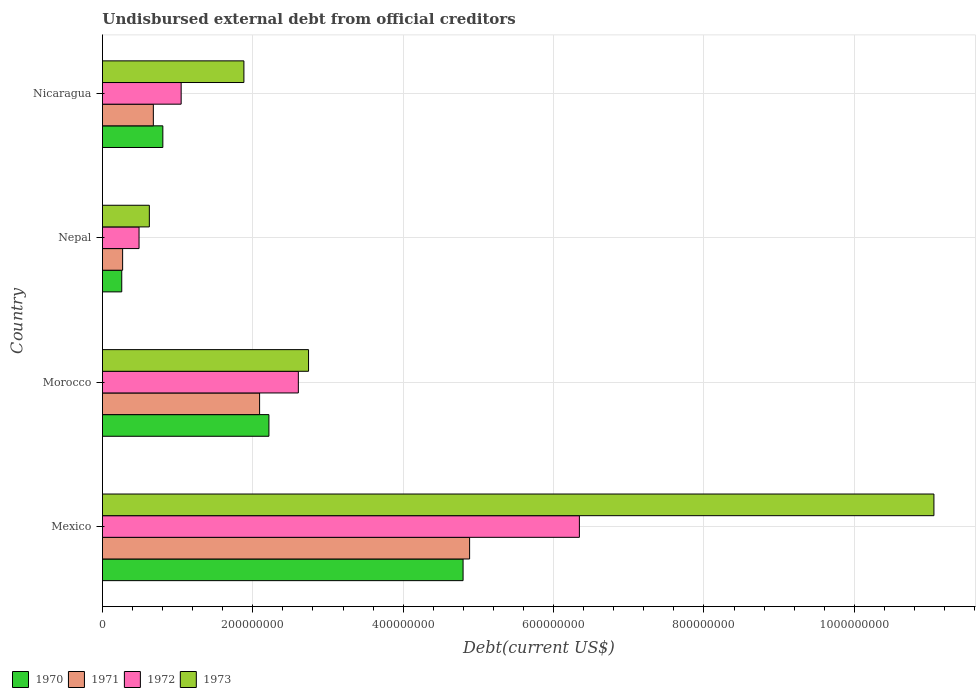How many different coloured bars are there?
Your answer should be very brief. 4. How many groups of bars are there?
Make the answer very short. 4. Are the number of bars per tick equal to the number of legend labels?
Ensure brevity in your answer.  Yes. Are the number of bars on each tick of the Y-axis equal?
Your response must be concise. Yes. How many bars are there on the 2nd tick from the top?
Provide a short and direct response. 4. What is the label of the 1st group of bars from the top?
Your answer should be compact. Nicaragua. In how many cases, is the number of bars for a given country not equal to the number of legend labels?
Keep it short and to the point. 0. What is the total debt in 1970 in Nicaragua?
Provide a succinct answer. 8.03e+07. Across all countries, what is the maximum total debt in 1973?
Your answer should be compact. 1.11e+09. Across all countries, what is the minimum total debt in 1972?
Offer a terse response. 4.87e+07. In which country was the total debt in 1972 minimum?
Provide a succinct answer. Nepal. What is the total total debt in 1973 in the graph?
Your answer should be very brief. 1.63e+09. What is the difference between the total debt in 1973 in Mexico and that in Nepal?
Your answer should be compact. 1.04e+09. What is the difference between the total debt in 1972 in Morocco and the total debt in 1971 in Mexico?
Your response must be concise. -2.28e+08. What is the average total debt in 1973 per country?
Your answer should be compact. 4.08e+08. What is the difference between the total debt in 1972 and total debt in 1971 in Nepal?
Offer a terse response. 2.18e+07. What is the ratio of the total debt in 1971 in Morocco to that in Nicaragua?
Give a very brief answer. 3.09. Is the difference between the total debt in 1972 in Mexico and Nepal greater than the difference between the total debt in 1971 in Mexico and Nepal?
Ensure brevity in your answer.  Yes. What is the difference between the highest and the second highest total debt in 1972?
Give a very brief answer. 3.74e+08. What is the difference between the highest and the lowest total debt in 1971?
Offer a terse response. 4.62e+08. In how many countries, is the total debt in 1973 greater than the average total debt in 1973 taken over all countries?
Provide a succinct answer. 1. Is the sum of the total debt in 1971 in Mexico and Nepal greater than the maximum total debt in 1973 across all countries?
Your answer should be very brief. No. Is it the case that in every country, the sum of the total debt in 1972 and total debt in 1973 is greater than the sum of total debt in 1970 and total debt in 1971?
Offer a very short reply. No. What does the 1st bar from the top in Nicaragua represents?
Offer a very short reply. 1973. What does the 4th bar from the bottom in Mexico represents?
Make the answer very short. 1973. How many countries are there in the graph?
Offer a very short reply. 4. What is the difference between two consecutive major ticks on the X-axis?
Provide a short and direct response. 2.00e+08. Does the graph contain any zero values?
Ensure brevity in your answer.  No. What is the title of the graph?
Your response must be concise. Undisbursed external debt from official creditors. Does "1998" appear as one of the legend labels in the graph?
Provide a short and direct response. No. What is the label or title of the X-axis?
Ensure brevity in your answer.  Debt(current US$). What is the Debt(current US$) in 1970 in Mexico?
Give a very brief answer. 4.80e+08. What is the Debt(current US$) in 1971 in Mexico?
Make the answer very short. 4.88e+08. What is the Debt(current US$) in 1972 in Mexico?
Keep it short and to the point. 6.34e+08. What is the Debt(current US$) in 1973 in Mexico?
Give a very brief answer. 1.11e+09. What is the Debt(current US$) in 1970 in Morocco?
Provide a short and direct response. 2.21e+08. What is the Debt(current US$) in 1971 in Morocco?
Offer a terse response. 2.09e+08. What is the Debt(current US$) in 1972 in Morocco?
Provide a short and direct response. 2.61e+08. What is the Debt(current US$) of 1973 in Morocco?
Keep it short and to the point. 2.74e+08. What is the Debt(current US$) of 1970 in Nepal?
Provide a succinct answer. 2.57e+07. What is the Debt(current US$) of 1971 in Nepal?
Your answer should be very brief. 2.68e+07. What is the Debt(current US$) of 1972 in Nepal?
Make the answer very short. 4.87e+07. What is the Debt(current US$) of 1973 in Nepal?
Make the answer very short. 6.23e+07. What is the Debt(current US$) in 1970 in Nicaragua?
Your answer should be compact. 8.03e+07. What is the Debt(current US$) in 1971 in Nicaragua?
Provide a succinct answer. 6.77e+07. What is the Debt(current US$) in 1972 in Nicaragua?
Offer a very short reply. 1.05e+08. What is the Debt(current US$) in 1973 in Nicaragua?
Give a very brief answer. 1.88e+08. Across all countries, what is the maximum Debt(current US$) in 1970?
Make the answer very short. 4.80e+08. Across all countries, what is the maximum Debt(current US$) in 1971?
Offer a terse response. 4.88e+08. Across all countries, what is the maximum Debt(current US$) in 1972?
Make the answer very short. 6.34e+08. Across all countries, what is the maximum Debt(current US$) of 1973?
Offer a very short reply. 1.11e+09. Across all countries, what is the minimum Debt(current US$) of 1970?
Keep it short and to the point. 2.57e+07. Across all countries, what is the minimum Debt(current US$) in 1971?
Give a very brief answer. 2.68e+07. Across all countries, what is the minimum Debt(current US$) in 1972?
Provide a succinct answer. 4.87e+07. Across all countries, what is the minimum Debt(current US$) of 1973?
Keep it short and to the point. 6.23e+07. What is the total Debt(current US$) of 1970 in the graph?
Your answer should be very brief. 8.07e+08. What is the total Debt(current US$) of 1971 in the graph?
Ensure brevity in your answer.  7.92e+08. What is the total Debt(current US$) of 1972 in the graph?
Your answer should be very brief. 1.05e+09. What is the total Debt(current US$) in 1973 in the graph?
Give a very brief answer. 1.63e+09. What is the difference between the Debt(current US$) in 1970 in Mexico and that in Morocco?
Give a very brief answer. 2.58e+08. What is the difference between the Debt(current US$) of 1971 in Mexico and that in Morocco?
Keep it short and to the point. 2.79e+08. What is the difference between the Debt(current US$) of 1972 in Mexico and that in Morocco?
Provide a short and direct response. 3.74e+08. What is the difference between the Debt(current US$) in 1973 in Mexico and that in Morocco?
Ensure brevity in your answer.  8.32e+08. What is the difference between the Debt(current US$) of 1970 in Mexico and that in Nepal?
Offer a terse response. 4.54e+08. What is the difference between the Debt(current US$) of 1971 in Mexico and that in Nepal?
Your answer should be compact. 4.62e+08. What is the difference between the Debt(current US$) of 1972 in Mexico and that in Nepal?
Provide a short and direct response. 5.86e+08. What is the difference between the Debt(current US$) in 1973 in Mexico and that in Nepal?
Make the answer very short. 1.04e+09. What is the difference between the Debt(current US$) of 1970 in Mexico and that in Nicaragua?
Offer a terse response. 3.99e+08. What is the difference between the Debt(current US$) of 1971 in Mexico and that in Nicaragua?
Your answer should be very brief. 4.21e+08. What is the difference between the Debt(current US$) of 1972 in Mexico and that in Nicaragua?
Make the answer very short. 5.30e+08. What is the difference between the Debt(current US$) of 1973 in Mexico and that in Nicaragua?
Your answer should be compact. 9.18e+08. What is the difference between the Debt(current US$) of 1970 in Morocco and that in Nepal?
Your answer should be compact. 1.96e+08. What is the difference between the Debt(current US$) in 1971 in Morocco and that in Nepal?
Ensure brevity in your answer.  1.82e+08. What is the difference between the Debt(current US$) of 1972 in Morocco and that in Nepal?
Keep it short and to the point. 2.12e+08. What is the difference between the Debt(current US$) of 1973 in Morocco and that in Nepal?
Your answer should be compact. 2.12e+08. What is the difference between the Debt(current US$) of 1970 in Morocco and that in Nicaragua?
Offer a very short reply. 1.41e+08. What is the difference between the Debt(current US$) in 1971 in Morocco and that in Nicaragua?
Offer a terse response. 1.41e+08. What is the difference between the Debt(current US$) of 1972 in Morocco and that in Nicaragua?
Keep it short and to the point. 1.56e+08. What is the difference between the Debt(current US$) in 1973 in Morocco and that in Nicaragua?
Your answer should be compact. 8.60e+07. What is the difference between the Debt(current US$) in 1970 in Nepal and that in Nicaragua?
Your answer should be compact. -5.47e+07. What is the difference between the Debt(current US$) in 1971 in Nepal and that in Nicaragua?
Your response must be concise. -4.08e+07. What is the difference between the Debt(current US$) of 1972 in Nepal and that in Nicaragua?
Your response must be concise. -5.60e+07. What is the difference between the Debt(current US$) of 1973 in Nepal and that in Nicaragua?
Your response must be concise. -1.26e+08. What is the difference between the Debt(current US$) in 1970 in Mexico and the Debt(current US$) in 1971 in Morocco?
Offer a terse response. 2.71e+08. What is the difference between the Debt(current US$) of 1970 in Mexico and the Debt(current US$) of 1972 in Morocco?
Your answer should be compact. 2.19e+08. What is the difference between the Debt(current US$) of 1970 in Mexico and the Debt(current US$) of 1973 in Morocco?
Your answer should be compact. 2.06e+08. What is the difference between the Debt(current US$) of 1971 in Mexico and the Debt(current US$) of 1972 in Morocco?
Ensure brevity in your answer.  2.28e+08. What is the difference between the Debt(current US$) of 1971 in Mexico and the Debt(current US$) of 1973 in Morocco?
Your response must be concise. 2.14e+08. What is the difference between the Debt(current US$) of 1972 in Mexico and the Debt(current US$) of 1973 in Morocco?
Ensure brevity in your answer.  3.60e+08. What is the difference between the Debt(current US$) in 1970 in Mexico and the Debt(current US$) in 1971 in Nepal?
Offer a very short reply. 4.53e+08. What is the difference between the Debt(current US$) in 1970 in Mexico and the Debt(current US$) in 1972 in Nepal?
Your response must be concise. 4.31e+08. What is the difference between the Debt(current US$) of 1970 in Mexico and the Debt(current US$) of 1973 in Nepal?
Ensure brevity in your answer.  4.17e+08. What is the difference between the Debt(current US$) of 1971 in Mexico and the Debt(current US$) of 1972 in Nepal?
Your answer should be very brief. 4.40e+08. What is the difference between the Debt(current US$) in 1971 in Mexico and the Debt(current US$) in 1973 in Nepal?
Provide a short and direct response. 4.26e+08. What is the difference between the Debt(current US$) of 1972 in Mexico and the Debt(current US$) of 1973 in Nepal?
Provide a succinct answer. 5.72e+08. What is the difference between the Debt(current US$) in 1970 in Mexico and the Debt(current US$) in 1971 in Nicaragua?
Your response must be concise. 4.12e+08. What is the difference between the Debt(current US$) in 1970 in Mexico and the Debt(current US$) in 1972 in Nicaragua?
Your response must be concise. 3.75e+08. What is the difference between the Debt(current US$) in 1970 in Mexico and the Debt(current US$) in 1973 in Nicaragua?
Offer a terse response. 2.92e+08. What is the difference between the Debt(current US$) in 1971 in Mexico and the Debt(current US$) in 1972 in Nicaragua?
Provide a short and direct response. 3.84e+08. What is the difference between the Debt(current US$) in 1971 in Mexico and the Debt(current US$) in 1973 in Nicaragua?
Keep it short and to the point. 3.00e+08. What is the difference between the Debt(current US$) in 1972 in Mexico and the Debt(current US$) in 1973 in Nicaragua?
Make the answer very short. 4.46e+08. What is the difference between the Debt(current US$) in 1970 in Morocco and the Debt(current US$) in 1971 in Nepal?
Your answer should be compact. 1.95e+08. What is the difference between the Debt(current US$) in 1970 in Morocco and the Debt(current US$) in 1972 in Nepal?
Offer a terse response. 1.73e+08. What is the difference between the Debt(current US$) in 1970 in Morocco and the Debt(current US$) in 1973 in Nepal?
Provide a succinct answer. 1.59e+08. What is the difference between the Debt(current US$) of 1971 in Morocco and the Debt(current US$) of 1972 in Nepal?
Offer a very short reply. 1.60e+08. What is the difference between the Debt(current US$) of 1971 in Morocco and the Debt(current US$) of 1973 in Nepal?
Offer a terse response. 1.47e+08. What is the difference between the Debt(current US$) of 1972 in Morocco and the Debt(current US$) of 1973 in Nepal?
Provide a succinct answer. 1.98e+08. What is the difference between the Debt(current US$) in 1970 in Morocco and the Debt(current US$) in 1971 in Nicaragua?
Ensure brevity in your answer.  1.54e+08. What is the difference between the Debt(current US$) in 1970 in Morocco and the Debt(current US$) in 1972 in Nicaragua?
Provide a succinct answer. 1.17e+08. What is the difference between the Debt(current US$) in 1970 in Morocco and the Debt(current US$) in 1973 in Nicaragua?
Provide a succinct answer. 3.33e+07. What is the difference between the Debt(current US$) of 1971 in Morocco and the Debt(current US$) of 1972 in Nicaragua?
Provide a short and direct response. 1.04e+08. What is the difference between the Debt(current US$) in 1971 in Morocco and the Debt(current US$) in 1973 in Nicaragua?
Offer a very short reply. 2.09e+07. What is the difference between the Debt(current US$) in 1972 in Morocco and the Debt(current US$) in 1973 in Nicaragua?
Your answer should be very brief. 7.24e+07. What is the difference between the Debt(current US$) of 1970 in Nepal and the Debt(current US$) of 1971 in Nicaragua?
Make the answer very short. -4.20e+07. What is the difference between the Debt(current US$) of 1970 in Nepal and the Debt(current US$) of 1972 in Nicaragua?
Your answer should be compact. -7.90e+07. What is the difference between the Debt(current US$) in 1970 in Nepal and the Debt(current US$) in 1973 in Nicaragua?
Keep it short and to the point. -1.62e+08. What is the difference between the Debt(current US$) in 1971 in Nepal and the Debt(current US$) in 1972 in Nicaragua?
Your response must be concise. -7.78e+07. What is the difference between the Debt(current US$) in 1971 in Nepal and the Debt(current US$) in 1973 in Nicaragua?
Make the answer very short. -1.61e+08. What is the difference between the Debt(current US$) in 1972 in Nepal and the Debt(current US$) in 1973 in Nicaragua?
Keep it short and to the point. -1.39e+08. What is the average Debt(current US$) in 1970 per country?
Ensure brevity in your answer.  2.02e+08. What is the average Debt(current US$) in 1971 per country?
Offer a terse response. 1.98e+08. What is the average Debt(current US$) in 1972 per country?
Your answer should be compact. 2.62e+08. What is the average Debt(current US$) of 1973 per country?
Your answer should be very brief. 4.08e+08. What is the difference between the Debt(current US$) of 1970 and Debt(current US$) of 1971 in Mexico?
Offer a very short reply. -8.70e+06. What is the difference between the Debt(current US$) in 1970 and Debt(current US$) in 1972 in Mexico?
Offer a terse response. -1.55e+08. What is the difference between the Debt(current US$) of 1970 and Debt(current US$) of 1973 in Mexico?
Give a very brief answer. -6.26e+08. What is the difference between the Debt(current US$) in 1971 and Debt(current US$) in 1972 in Mexico?
Keep it short and to the point. -1.46e+08. What is the difference between the Debt(current US$) in 1971 and Debt(current US$) in 1973 in Mexico?
Your response must be concise. -6.18e+08. What is the difference between the Debt(current US$) of 1972 and Debt(current US$) of 1973 in Mexico?
Give a very brief answer. -4.72e+08. What is the difference between the Debt(current US$) in 1970 and Debt(current US$) in 1971 in Morocco?
Provide a short and direct response. 1.24e+07. What is the difference between the Debt(current US$) of 1970 and Debt(current US$) of 1972 in Morocco?
Your answer should be compact. -3.91e+07. What is the difference between the Debt(current US$) of 1970 and Debt(current US$) of 1973 in Morocco?
Your answer should be very brief. -5.27e+07. What is the difference between the Debt(current US$) of 1971 and Debt(current US$) of 1972 in Morocco?
Your answer should be compact. -5.15e+07. What is the difference between the Debt(current US$) in 1971 and Debt(current US$) in 1973 in Morocco?
Your answer should be very brief. -6.51e+07. What is the difference between the Debt(current US$) in 1972 and Debt(current US$) in 1973 in Morocco?
Ensure brevity in your answer.  -1.36e+07. What is the difference between the Debt(current US$) in 1970 and Debt(current US$) in 1971 in Nepal?
Your answer should be compact. -1.17e+06. What is the difference between the Debt(current US$) in 1970 and Debt(current US$) in 1972 in Nepal?
Your answer should be very brief. -2.30e+07. What is the difference between the Debt(current US$) in 1970 and Debt(current US$) in 1973 in Nepal?
Ensure brevity in your answer.  -3.67e+07. What is the difference between the Debt(current US$) of 1971 and Debt(current US$) of 1972 in Nepal?
Provide a succinct answer. -2.18e+07. What is the difference between the Debt(current US$) in 1971 and Debt(current US$) in 1973 in Nepal?
Your answer should be compact. -3.55e+07. What is the difference between the Debt(current US$) in 1972 and Debt(current US$) in 1973 in Nepal?
Your answer should be very brief. -1.37e+07. What is the difference between the Debt(current US$) in 1970 and Debt(current US$) in 1971 in Nicaragua?
Keep it short and to the point. 1.26e+07. What is the difference between the Debt(current US$) in 1970 and Debt(current US$) in 1972 in Nicaragua?
Ensure brevity in your answer.  -2.44e+07. What is the difference between the Debt(current US$) in 1970 and Debt(current US$) in 1973 in Nicaragua?
Your response must be concise. -1.08e+08. What is the difference between the Debt(current US$) of 1971 and Debt(current US$) of 1972 in Nicaragua?
Your answer should be compact. -3.70e+07. What is the difference between the Debt(current US$) in 1971 and Debt(current US$) in 1973 in Nicaragua?
Your response must be concise. -1.20e+08. What is the difference between the Debt(current US$) in 1972 and Debt(current US$) in 1973 in Nicaragua?
Your answer should be compact. -8.35e+07. What is the ratio of the Debt(current US$) of 1970 in Mexico to that in Morocco?
Offer a terse response. 2.17. What is the ratio of the Debt(current US$) in 1971 in Mexico to that in Morocco?
Make the answer very short. 2.34. What is the ratio of the Debt(current US$) in 1972 in Mexico to that in Morocco?
Make the answer very short. 2.43. What is the ratio of the Debt(current US$) of 1973 in Mexico to that in Morocco?
Provide a short and direct response. 4.03. What is the ratio of the Debt(current US$) of 1970 in Mexico to that in Nepal?
Offer a very short reply. 18.7. What is the ratio of the Debt(current US$) of 1971 in Mexico to that in Nepal?
Ensure brevity in your answer.  18.21. What is the ratio of the Debt(current US$) in 1972 in Mexico to that in Nepal?
Your response must be concise. 13.04. What is the ratio of the Debt(current US$) in 1973 in Mexico to that in Nepal?
Give a very brief answer. 17.74. What is the ratio of the Debt(current US$) in 1970 in Mexico to that in Nicaragua?
Offer a very short reply. 5.97. What is the ratio of the Debt(current US$) of 1971 in Mexico to that in Nicaragua?
Offer a terse response. 7.22. What is the ratio of the Debt(current US$) in 1972 in Mexico to that in Nicaragua?
Give a very brief answer. 6.06. What is the ratio of the Debt(current US$) of 1973 in Mexico to that in Nicaragua?
Keep it short and to the point. 5.88. What is the ratio of the Debt(current US$) in 1970 in Morocco to that in Nepal?
Your answer should be compact. 8.63. What is the ratio of the Debt(current US$) of 1971 in Morocco to that in Nepal?
Give a very brief answer. 7.79. What is the ratio of the Debt(current US$) in 1972 in Morocco to that in Nepal?
Ensure brevity in your answer.  5.35. What is the ratio of the Debt(current US$) in 1973 in Morocco to that in Nepal?
Make the answer very short. 4.4. What is the ratio of the Debt(current US$) of 1970 in Morocco to that in Nicaragua?
Your response must be concise. 2.76. What is the ratio of the Debt(current US$) in 1971 in Morocco to that in Nicaragua?
Offer a very short reply. 3.09. What is the ratio of the Debt(current US$) in 1972 in Morocco to that in Nicaragua?
Your answer should be compact. 2.49. What is the ratio of the Debt(current US$) of 1973 in Morocco to that in Nicaragua?
Your response must be concise. 1.46. What is the ratio of the Debt(current US$) of 1970 in Nepal to that in Nicaragua?
Ensure brevity in your answer.  0.32. What is the ratio of the Debt(current US$) in 1971 in Nepal to that in Nicaragua?
Ensure brevity in your answer.  0.4. What is the ratio of the Debt(current US$) of 1972 in Nepal to that in Nicaragua?
Provide a short and direct response. 0.46. What is the ratio of the Debt(current US$) in 1973 in Nepal to that in Nicaragua?
Ensure brevity in your answer.  0.33. What is the difference between the highest and the second highest Debt(current US$) in 1970?
Provide a succinct answer. 2.58e+08. What is the difference between the highest and the second highest Debt(current US$) of 1971?
Your answer should be very brief. 2.79e+08. What is the difference between the highest and the second highest Debt(current US$) in 1972?
Offer a terse response. 3.74e+08. What is the difference between the highest and the second highest Debt(current US$) in 1973?
Your answer should be very brief. 8.32e+08. What is the difference between the highest and the lowest Debt(current US$) of 1970?
Offer a terse response. 4.54e+08. What is the difference between the highest and the lowest Debt(current US$) in 1971?
Offer a very short reply. 4.62e+08. What is the difference between the highest and the lowest Debt(current US$) in 1972?
Keep it short and to the point. 5.86e+08. What is the difference between the highest and the lowest Debt(current US$) in 1973?
Provide a succinct answer. 1.04e+09. 